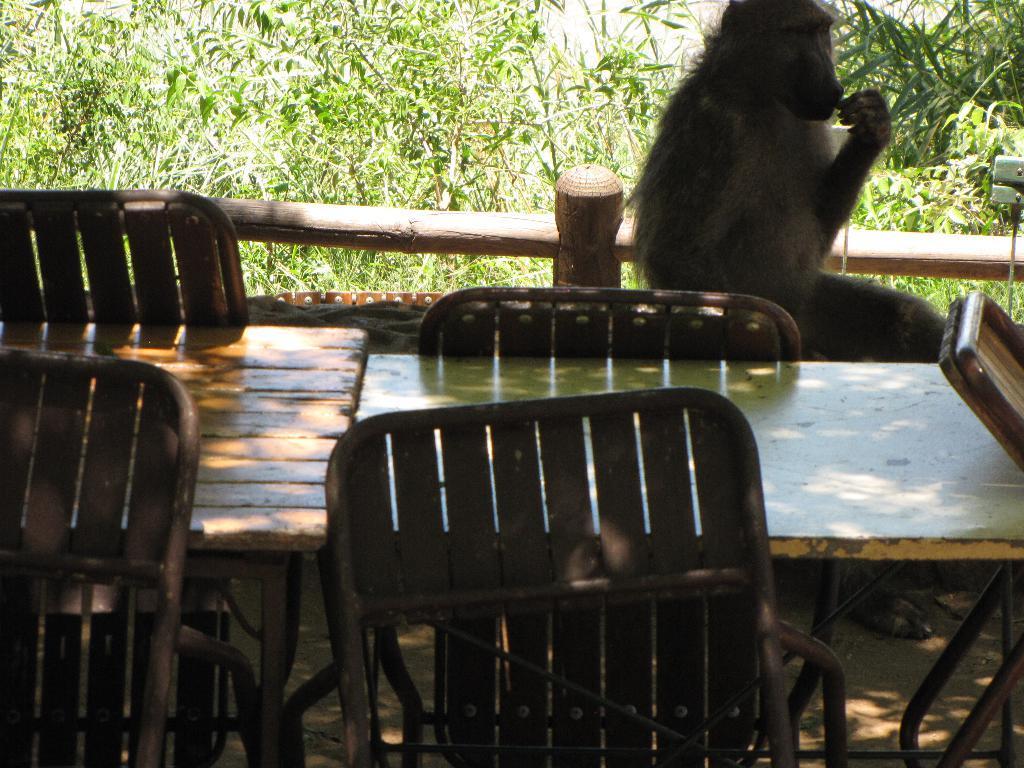How would you summarize this image in a sentence or two? This image is clicked outside the city. In the front, there is a table along with chairs. Beside that there is a money sitting. In the background, there are trees. 